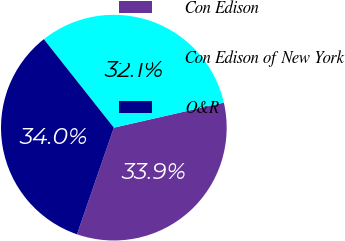Convert chart to OTSL. <chart><loc_0><loc_0><loc_500><loc_500><pie_chart><fcel>Con Edison<fcel>Con Edison of New York<fcel>O&R<nl><fcel>33.86%<fcel>32.09%<fcel>34.05%<nl></chart> 